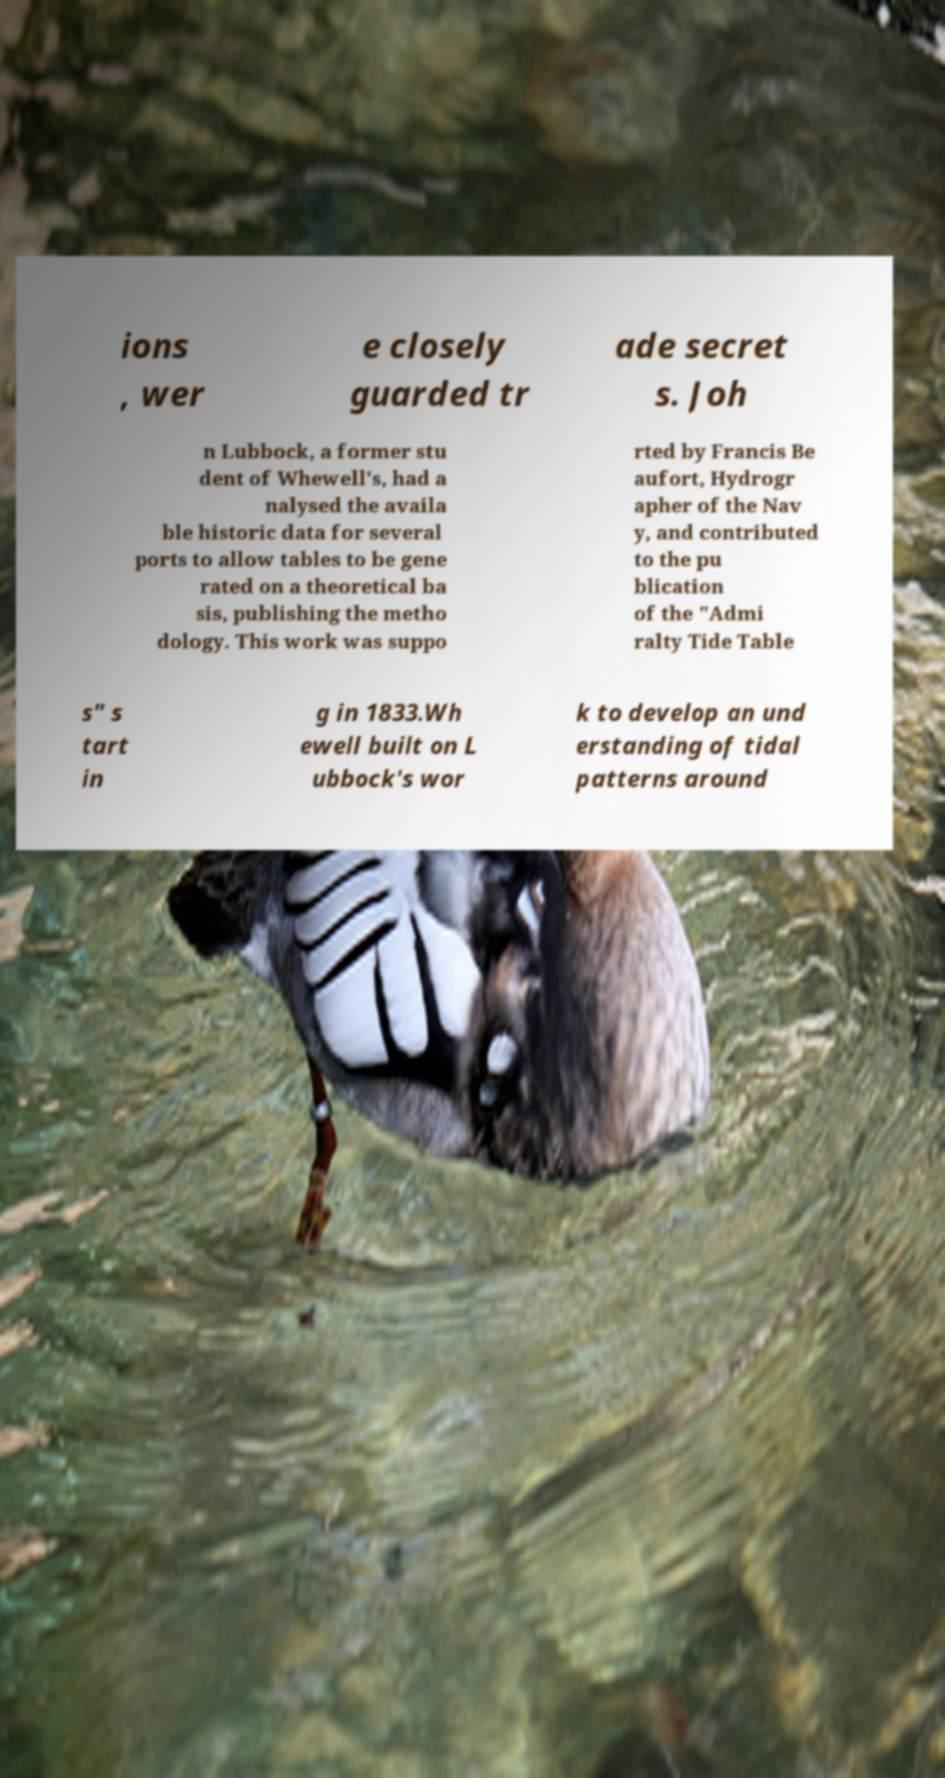Please identify and transcribe the text found in this image. ions , wer e closely guarded tr ade secret s. Joh n Lubbock, a former stu dent of Whewell's, had a nalysed the availa ble historic data for several ports to allow tables to be gene rated on a theoretical ba sis, publishing the metho dology. This work was suppo rted by Francis Be aufort, Hydrogr apher of the Nav y, and contributed to the pu blication of the "Admi ralty Tide Table s" s tart in g in 1833.Wh ewell built on L ubbock's wor k to develop an und erstanding of tidal patterns around 